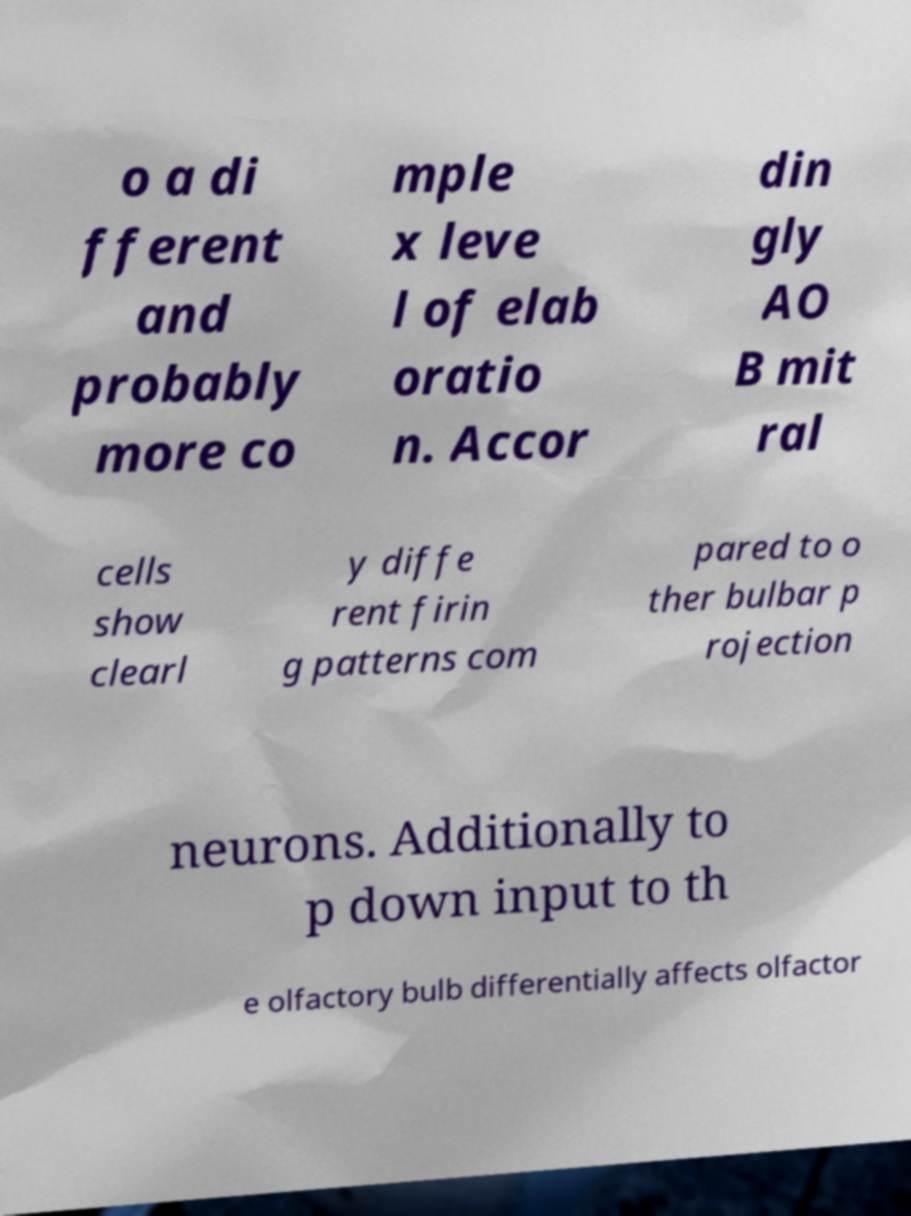For documentation purposes, I need the text within this image transcribed. Could you provide that? o a di fferent and probably more co mple x leve l of elab oratio n. Accor din gly AO B mit ral cells show clearl y diffe rent firin g patterns com pared to o ther bulbar p rojection neurons. Additionally to p down input to th e olfactory bulb differentially affects olfactor 